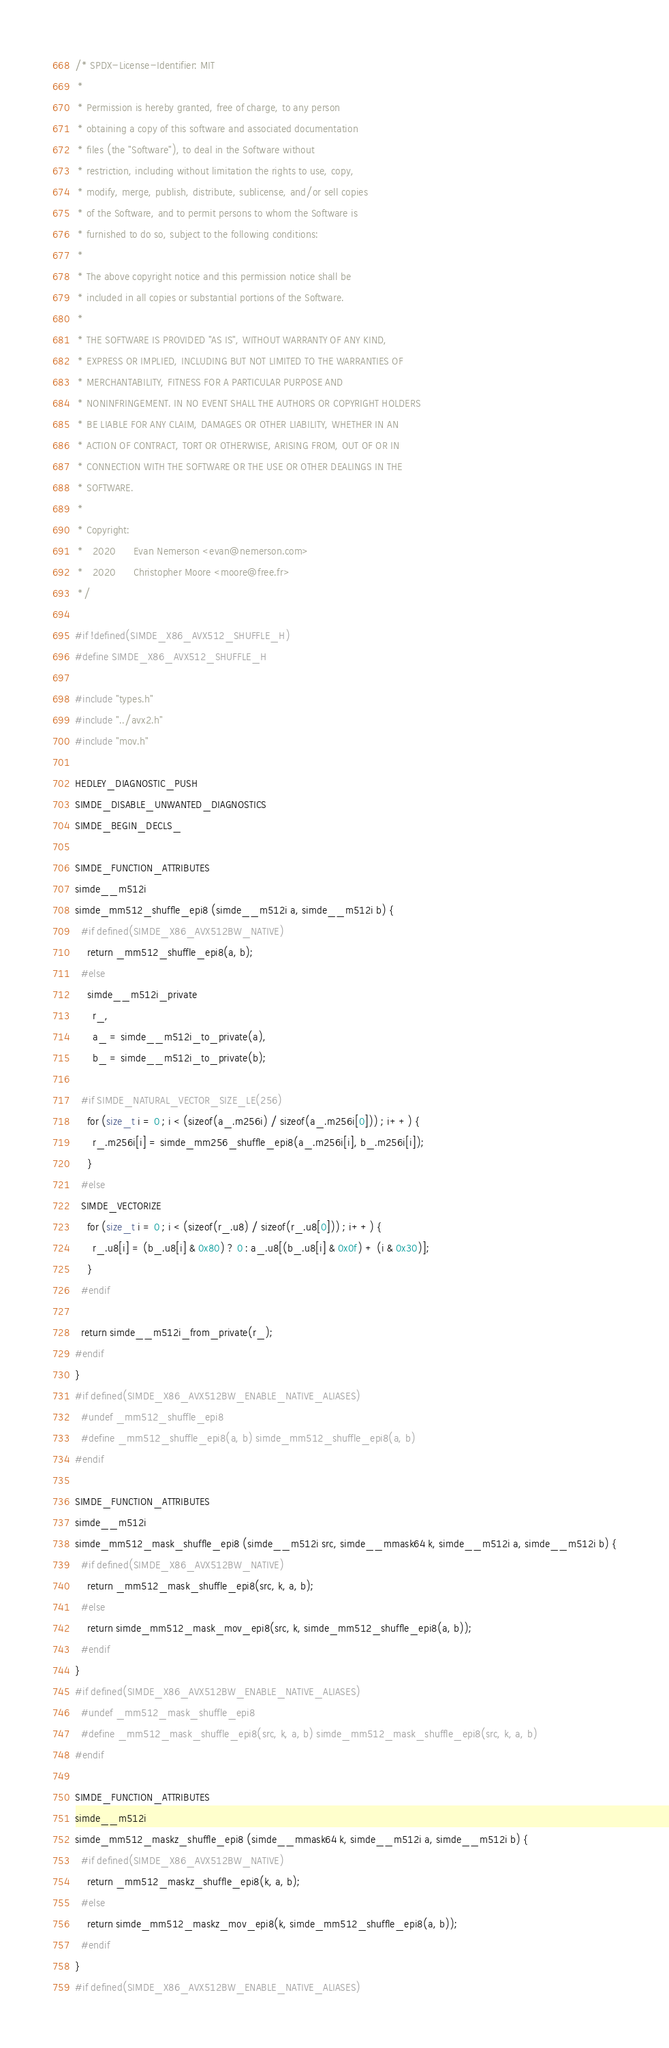Convert code to text. <code><loc_0><loc_0><loc_500><loc_500><_C_>/* SPDX-License-Identifier: MIT
 *
 * Permission is hereby granted, free of charge, to any person
 * obtaining a copy of this software and associated documentation
 * files (the "Software"), to deal in the Software without
 * restriction, including without limitation the rights to use, copy,
 * modify, merge, publish, distribute, sublicense, and/or sell copies
 * of the Software, and to permit persons to whom the Software is
 * furnished to do so, subject to the following conditions:
 *
 * The above copyright notice and this permission notice shall be
 * included in all copies or substantial portions of the Software.
 *
 * THE SOFTWARE IS PROVIDED "AS IS", WITHOUT WARRANTY OF ANY KIND,
 * EXPRESS OR IMPLIED, INCLUDING BUT NOT LIMITED TO THE WARRANTIES OF
 * MERCHANTABILITY, FITNESS FOR A PARTICULAR PURPOSE AND
 * NONINFRINGEMENT. IN NO EVENT SHALL THE AUTHORS OR COPYRIGHT HOLDERS
 * BE LIABLE FOR ANY CLAIM, DAMAGES OR OTHER LIABILITY, WHETHER IN AN
 * ACTION OF CONTRACT, TORT OR OTHERWISE, ARISING FROM, OUT OF OR IN
 * CONNECTION WITH THE SOFTWARE OR THE USE OR OTHER DEALINGS IN THE
 * SOFTWARE.
 *
 * Copyright:
 *   2020      Evan Nemerson <evan@nemerson.com>
 *   2020      Christopher Moore <moore@free.fr>
 */

#if !defined(SIMDE_X86_AVX512_SHUFFLE_H)
#define SIMDE_X86_AVX512_SHUFFLE_H

#include "types.h"
#include "../avx2.h"
#include "mov.h"

HEDLEY_DIAGNOSTIC_PUSH
SIMDE_DISABLE_UNWANTED_DIAGNOSTICS
SIMDE_BEGIN_DECLS_

SIMDE_FUNCTION_ATTRIBUTES
simde__m512i
simde_mm512_shuffle_epi8 (simde__m512i a, simde__m512i b) {
  #if defined(SIMDE_X86_AVX512BW_NATIVE)
    return _mm512_shuffle_epi8(a, b);
  #else
    simde__m512i_private
      r_,
      a_ = simde__m512i_to_private(a),
      b_ = simde__m512i_to_private(b);

  #if SIMDE_NATURAL_VECTOR_SIZE_LE(256)
    for (size_t i = 0 ; i < (sizeof(a_.m256i) / sizeof(a_.m256i[0])) ; i++) {
      r_.m256i[i] = simde_mm256_shuffle_epi8(a_.m256i[i], b_.m256i[i]);
    }
  #else
  SIMDE_VECTORIZE
    for (size_t i = 0 ; i < (sizeof(r_.u8) / sizeof(r_.u8[0])) ; i++) {
      r_.u8[i] = (b_.u8[i] & 0x80) ? 0 : a_.u8[(b_.u8[i] & 0x0f) + (i & 0x30)];
    }
  #endif

  return simde__m512i_from_private(r_);
#endif
}
#if defined(SIMDE_X86_AVX512BW_ENABLE_NATIVE_ALIASES)
  #undef _mm512_shuffle_epi8
  #define _mm512_shuffle_epi8(a, b) simde_mm512_shuffle_epi8(a, b)
#endif

SIMDE_FUNCTION_ATTRIBUTES
simde__m512i
simde_mm512_mask_shuffle_epi8 (simde__m512i src, simde__mmask64 k, simde__m512i a, simde__m512i b) {
  #if defined(SIMDE_X86_AVX512BW_NATIVE)
    return _mm512_mask_shuffle_epi8(src, k, a, b);
  #else
    return simde_mm512_mask_mov_epi8(src, k, simde_mm512_shuffle_epi8(a, b));
  #endif
}
#if defined(SIMDE_X86_AVX512BW_ENABLE_NATIVE_ALIASES)
  #undef _mm512_mask_shuffle_epi8
  #define _mm512_mask_shuffle_epi8(src, k, a, b) simde_mm512_mask_shuffle_epi8(src, k, a, b)
#endif

SIMDE_FUNCTION_ATTRIBUTES
simde__m512i
simde_mm512_maskz_shuffle_epi8 (simde__mmask64 k, simde__m512i a, simde__m512i b) {
  #if defined(SIMDE_X86_AVX512BW_NATIVE)
    return _mm512_maskz_shuffle_epi8(k, a, b);
  #else
    return simde_mm512_maskz_mov_epi8(k, simde_mm512_shuffle_epi8(a, b));
  #endif
}
#if defined(SIMDE_X86_AVX512BW_ENABLE_NATIVE_ALIASES)</code> 